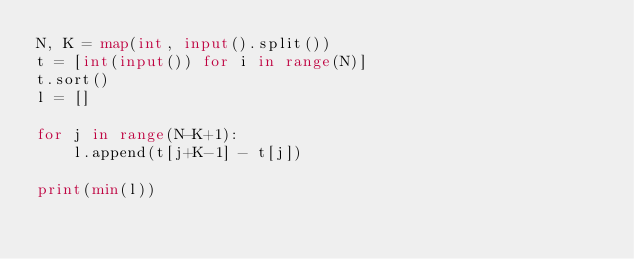Convert code to text. <code><loc_0><loc_0><loc_500><loc_500><_Python_>N, K = map(int, input().split())
t = [int(input()) for i in range(N)]
t.sort()
l = []

for j in range(N-K+1):
    l.append(t[j+K-1] - t[j])

print(min(l))</code> 